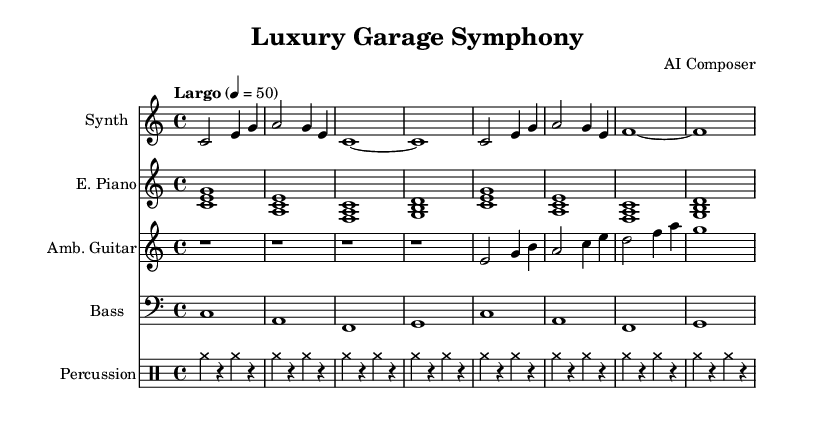What is the key signature of this music? The key signature is indicated at the beginning of the score. It is C major, which has no sharps or flats.
Answer: C major What is the time signature of the piece? The time signature is represented by the numerical values after the key signature. It shows that there are four beats in a measure. Thus, it is 4/4.
Answer: 4/4 What is the tempo marking of the composition? The tempo is indicated at the start of the score, stating the speed. It says "Largo" with a metronome marking of quarter note equals 50.
Answer: Largo, 50 How many measures are there in the synthesizer melody? By counting the distinct rhythmic groupings or bars shown on the staff for the synthesizer part, you can determine the total number of measures. There are 4 measures.
Answer: 4 What instrument is labeled for the ambient guitar part? The ambient guitar part is labeled at the start of its staff, specifically indicating "Amb. Guitar."
Answer: Amb. Guitar How does the percussion pattern appear in the score? The percussion patterns exhibit a consistent rhythmic structure, with repeated measures that utilize cymbals. The rhythm is denoted by the cymbals and rests in the drumming staff.
Answer: Repeated cymbals 